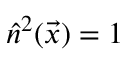Convert formula to latex. <formula><loc_0><loc_0><loc_500><loc_500>\hat { n } ^ { 2 } ( \vec { x } ) = 1</formula> 